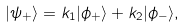Convert formula to latex. <formula><loc_0><loc_0><loc_500><loc_500>| \psi _ { + } \rangle = k _ { 1 } | \phi _ { + } \rangle + k _ { 2 } | \phi _ { - } \rangle ,</formula> 